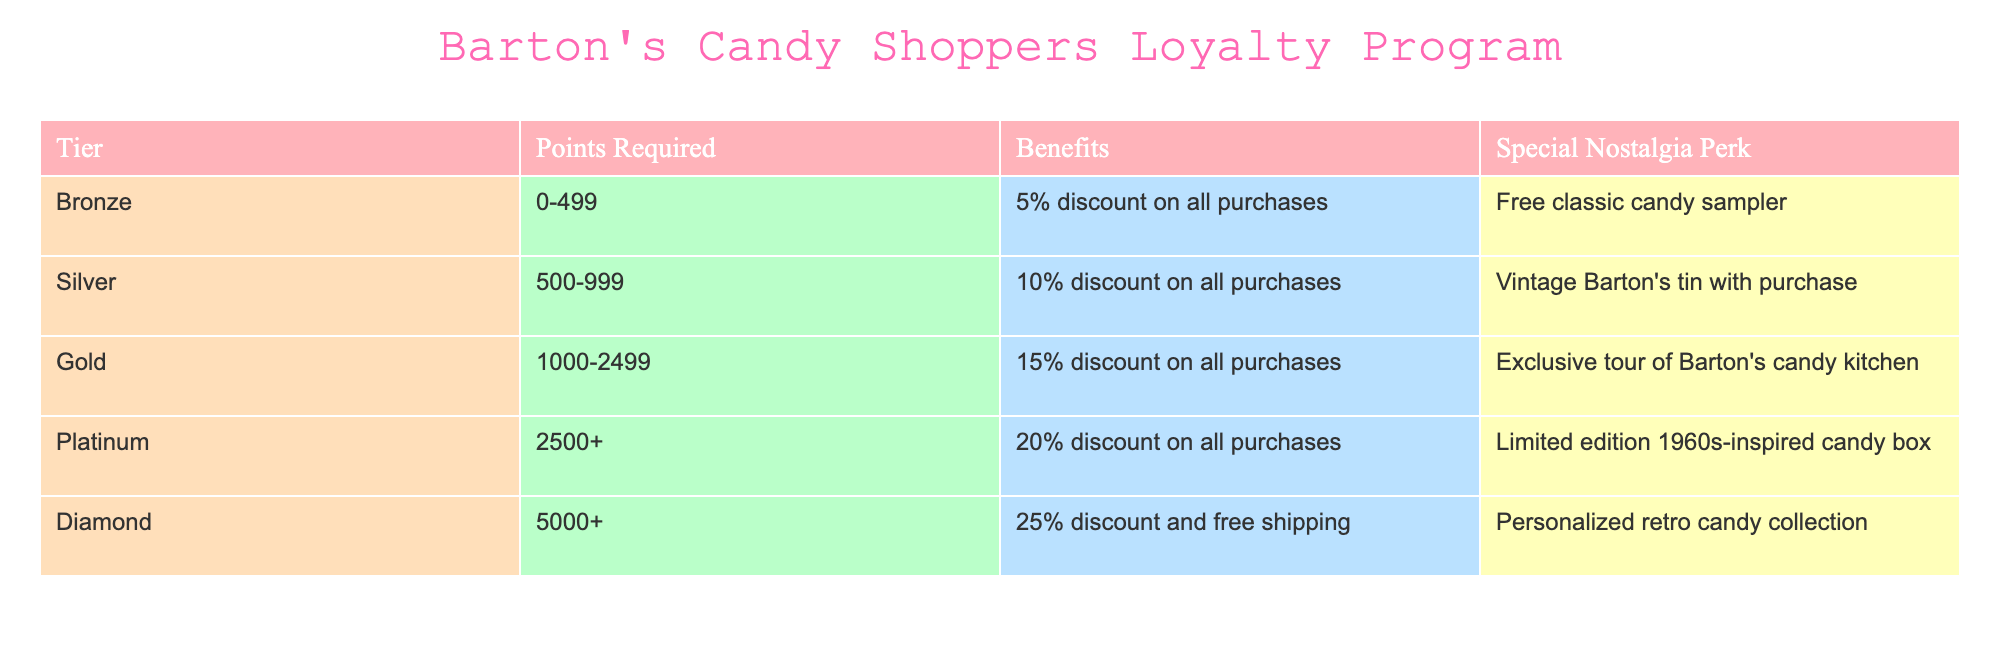What benefits do you receive at the Gold tier? The Gold tier offers a 15% discount on all purchases along with an exclusive tour of Barton's candy kitchen.
Answer: 15% discount and exclusive tour of Barton's candy kitchen How many points do you need to reach the Platinum tier? The Platinum tier requires a minimum of 2500 points.
Answer: 2500 points Is there a benefit associated with the Bronze tier? Yes, the Bronze tier provides a 5% discount on all purchases and a free classic candy sampler.
Answer: Yes What is the special nostalgia perk for Silver-tier members? The special nostalgia perk for Silver-tier members is a vintage Barton's tin with purchase.
Answer: Vintage Barton's tin with purchase At which tier do you receive a personalized retro candy collection? The personalized retro candy collection is received at the Diamond tier, which requires 5000 points or more.
Answer: Diamond tier If a customer with 600 points upgrades to the Gold tier, how much discount will they lose? Customers in the Silver tier receive a 10% discount, while the Gold tier offers a 15% discount, so they would not lose any discount; instead, they gain a 5% increase when upgrading.
Answer: Gain of 5% What is the average discount provided at the Silver and Gold tiers combined? The Silver tier provides a 10% discount and the Gold tier provides a 15% discount, so the average discount is (10 + 15) / 2 = 12.5%.
Answer: 12.5% Do all tiers have a discount associated with them? Yes, every tier listed has a discount benefit associated with it, starting from 5% at the Bronze tier to 25% at the Diamond tier.
Answer: Yes How many total points are required to move from Bronze to Platinum tier? To move from Bronze to Platinum tier, a customer needs to accumulate 2500 points from the Bronze starting point of 0, thus requiring 2500 total points.
Answer: 2500 points 